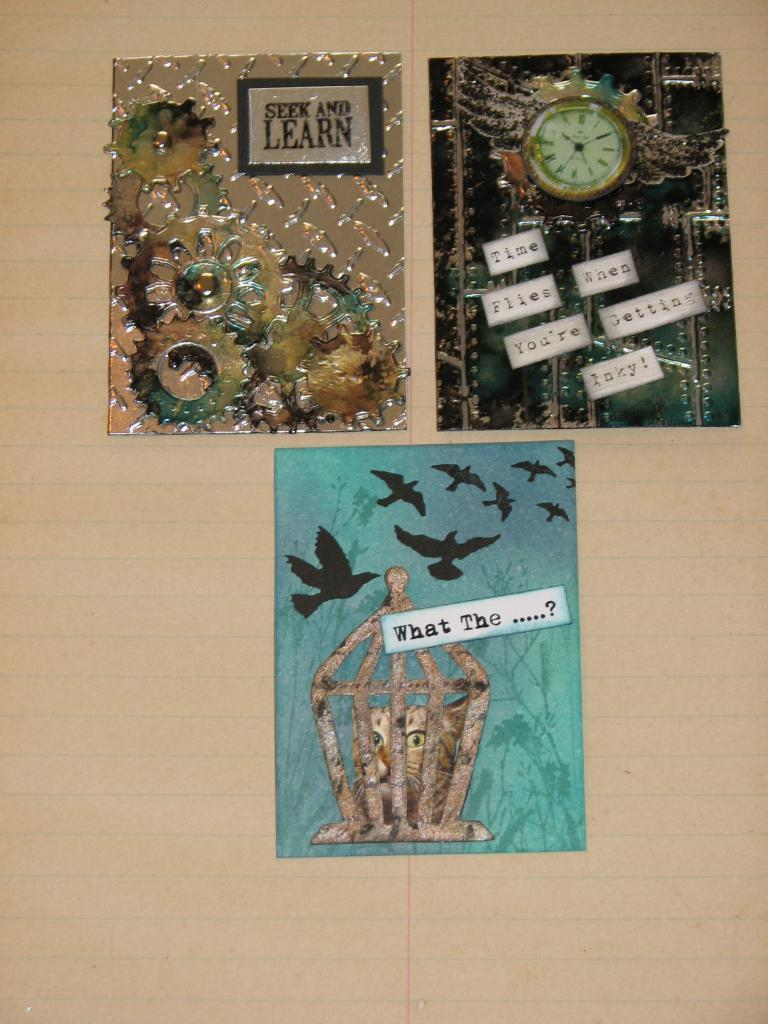<image>
Offer a succinct explanation of the picture presented. Three pieces of artwork with slogans on them, including "seek and learn". 